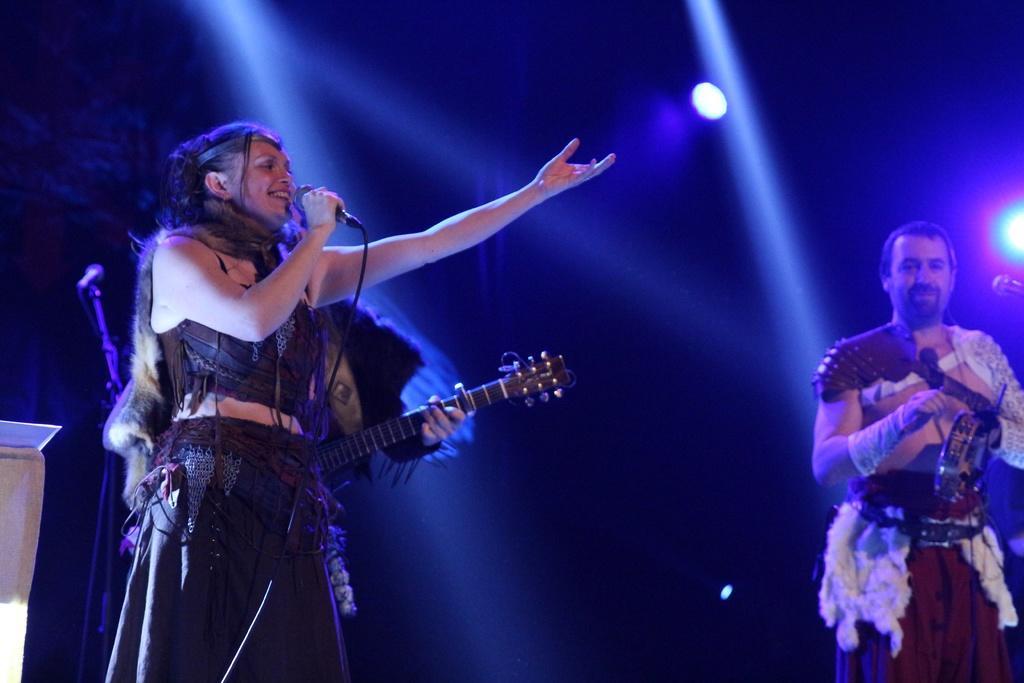Could you give a brief overview of what you see in this image? In this picture we can see a woman who is singing on the mike. She is smiling. Here we can see a man who is playing some musical instruments. And on the background there is a light. 